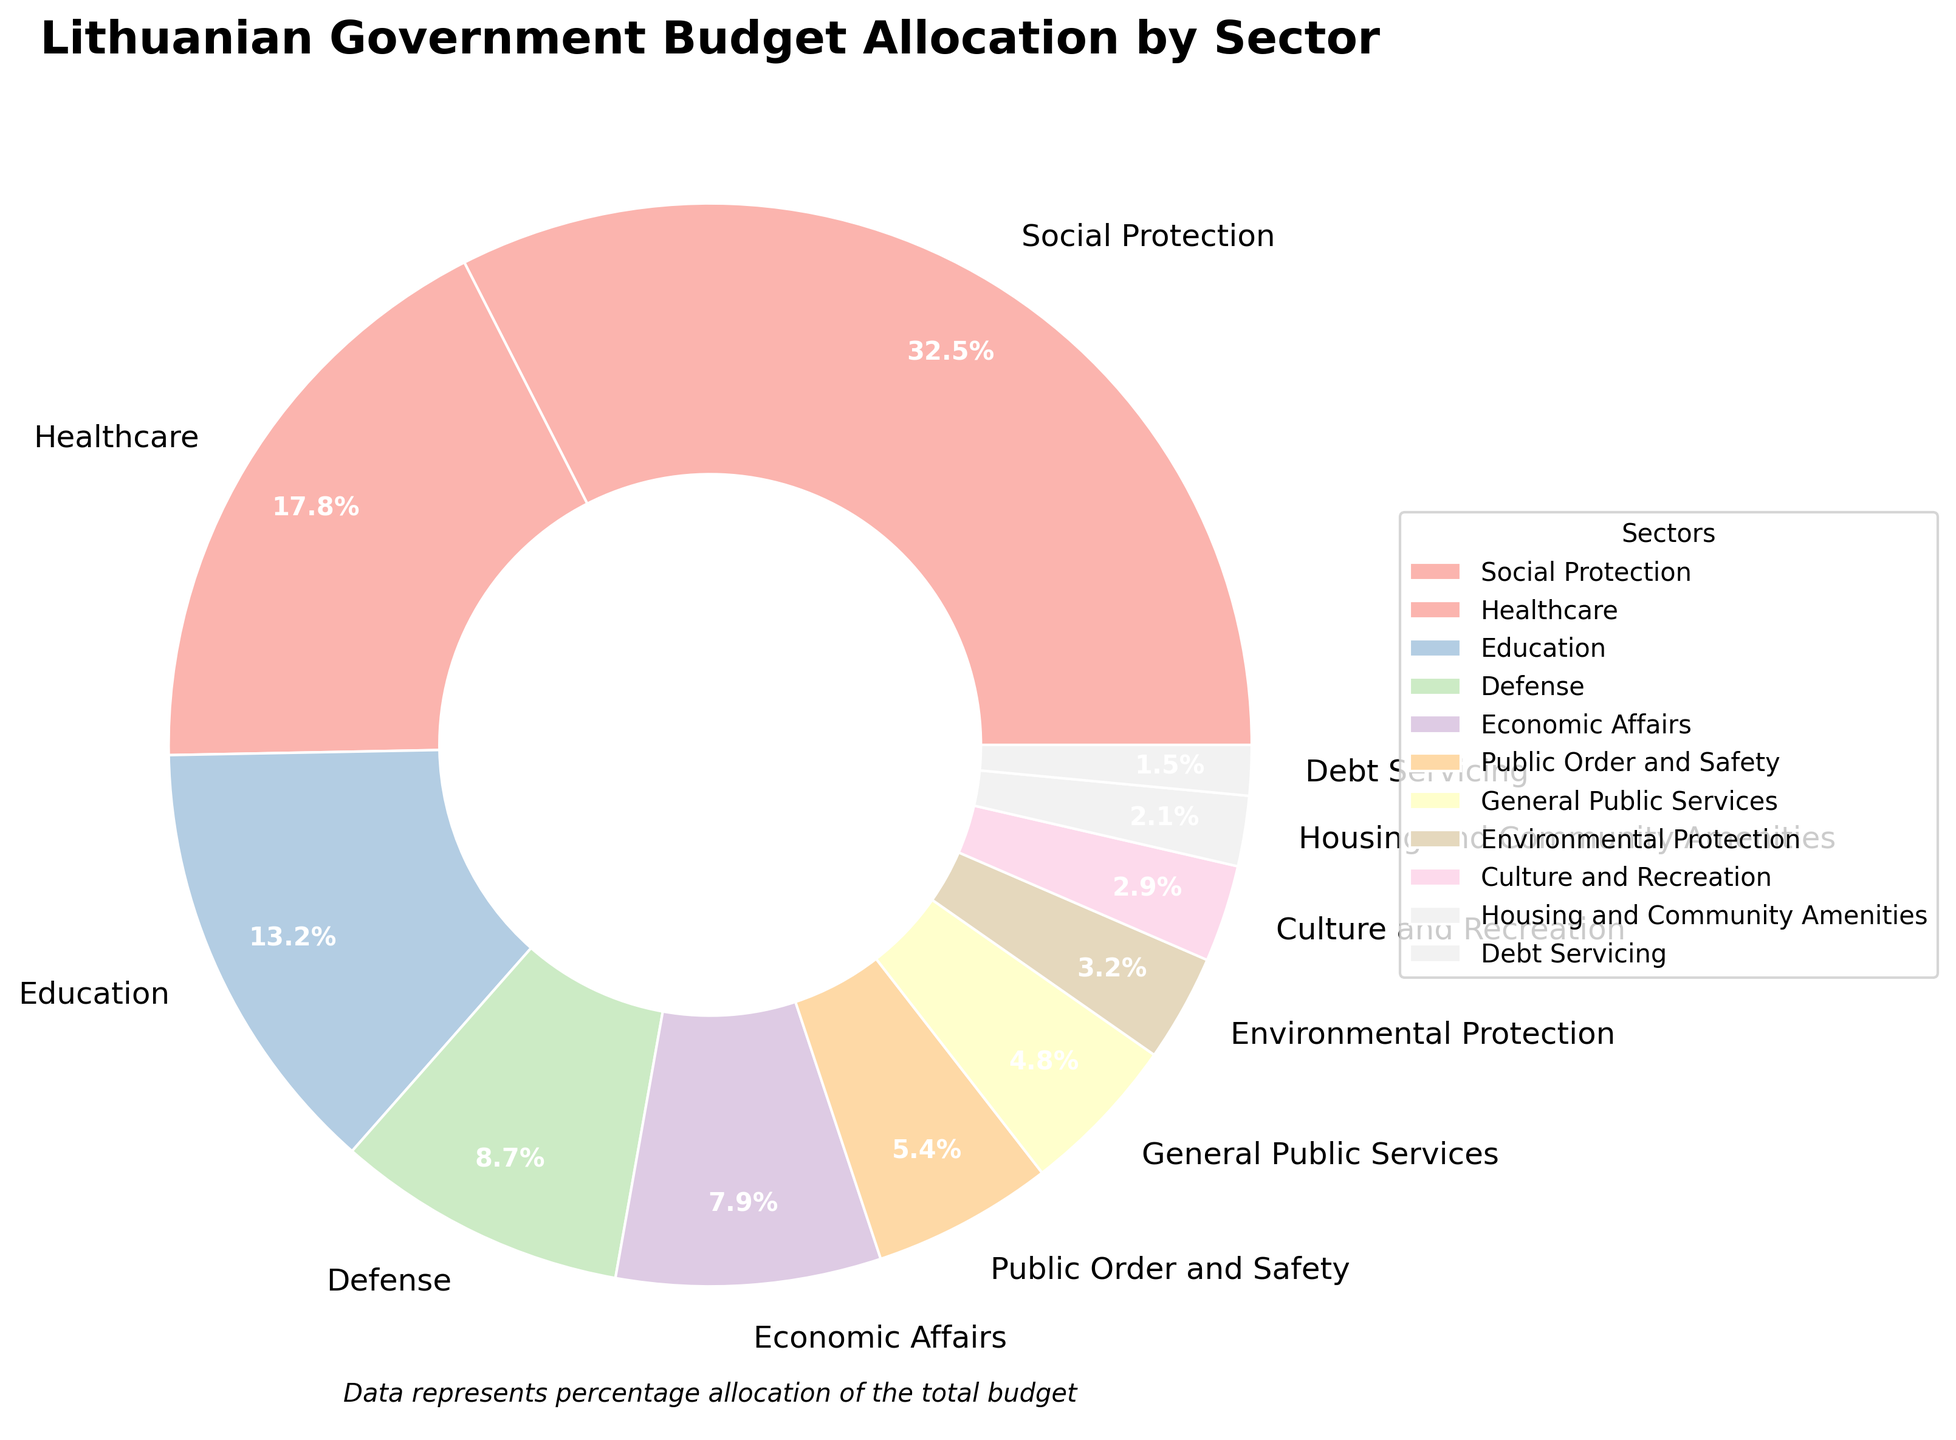Which sector has the highest budget allocation? By looking at the pie chart, the sector with the largest wedge represents the highest percentage. The Social Protection sector has the biggest percentage at 32.5%.
Answer: Social Protection Which sector has the lowest budget allocation? The smallest wedge in the pie chart represents the lowest percentage. The Debt Servicing sector is the smallest at 1.5%.
Answer: Debt Servicing What is the total percentage of budget allocation for Healthcare and Education combined? Add the percentages of Healthcare (17.8%) and Education (13.2%). 17.8% + 13.2% = 31.0%.
Answer: 31.0% How much more is allocated to Defense compared to Economic Affairs? Subtract the percentage of Economic Affairs (7.9%) from the percentage of Defense (8.7%). 8.7% - 7.9% = 0.8%.
Answer: 0.8% What is the difference in percentage between the highest and lowest allocated sectors? Subtract the percentage of the lowest sector (Debt Servicing at 1.5%) from the highest sector (Social Protection at 32.5%). 32.5% - 1.5% = 31.0%.
Answer: 31.0% Which two sectors combined make up 10% of the budget allocation? Identify two sectors whose combined percentages equal 10%. Public Order and Safety (5.4%) + General Public Services (4.8%) equals 10.2%, which is closest to 10%.
Answer: Public Order and Safety and General Public Services What is the average budget percentage allocated to sectors with more than 10% funding? Sum the percentages of sectors with more than 10% (Social Protection 32.5%, Healthcare 17.8%, Education 13.2%), then divide by 3. (32.5 + 17.8 + 13.2) / 3 = 21.17%.
Answer: 21.17% Among Culture and Recreation, Environmental Protection, and Housing and Community Amenities, which sector receives the highest budget allocation? Compare the percentages of the three sectors: Culture and Recreation (2.9%), Environmental Protection (3.2%), and Housing and Community Amenities (2.1%). The Environmental Protection sector has the highest at 3.2%.
Answer: Environmental Protection What proportion of the budget is allocated to Defence relative to Education? Divide the percentage of Defence (8.7%) by the percentage of Education (13.2%). 8.7% / 13.2% = 0.659, or approximately 65.9%.
Answer: 65.9% If the budget for Debt Servicing were to double, what would the new percentage be and would it change its ranking among the sectors? Double the percentage of Debt Servicing (1.5%), making it 3.0%. It would then rank above Housing and Community Amenities (2.1%) and below Culture and Recreation (2.9%).
Answer: 3.0%, ranking above Housing and Community Amenities 